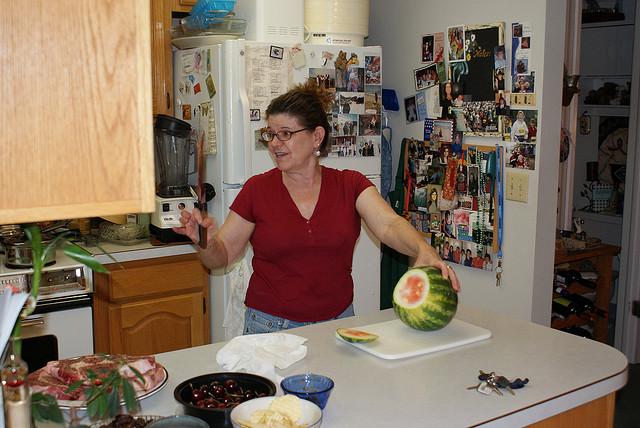What is being cut?
Write a very short answer. Watermelon. What season would this picture have been taken in?
Concise answer only. Summer. What is the flower pot made of?
Quick response, please. Clay. Is there a block with knives on the counter?
Write a very short answer. No. What is the color of the knife she is using?
Answer briefly. Brown. Are there photos in the background?
Give a very brief answer. Yes. How many melons are on display?
Write a very short answer. 1. What fruit is she cutting?
Give a very brief answer. Watermelon. Is this a normal location for a dining table?
Answer briefly. No. What surface is the fruit being cut on?
Keep it brief. Cutting board. 